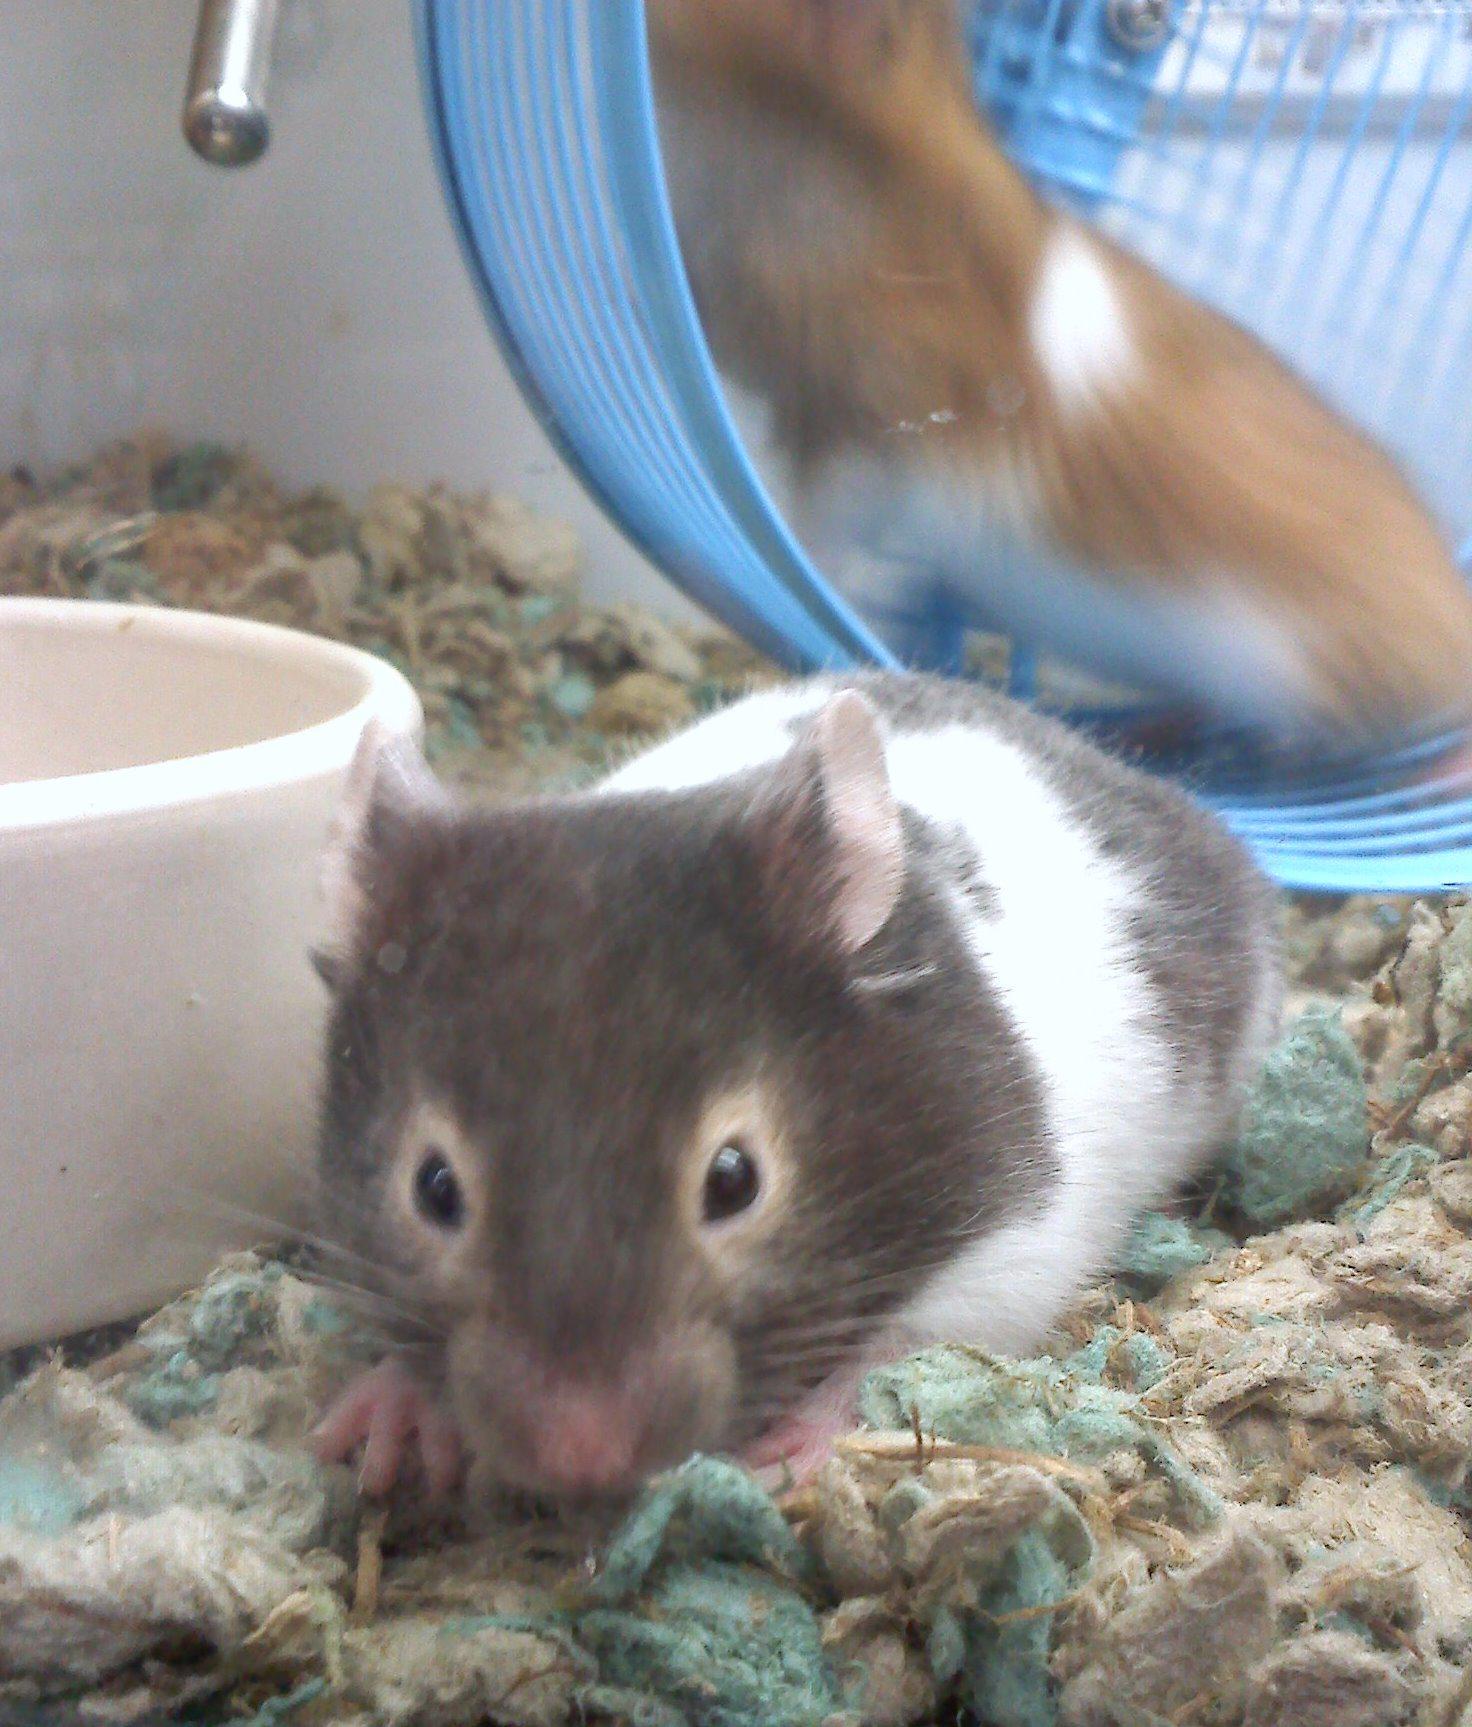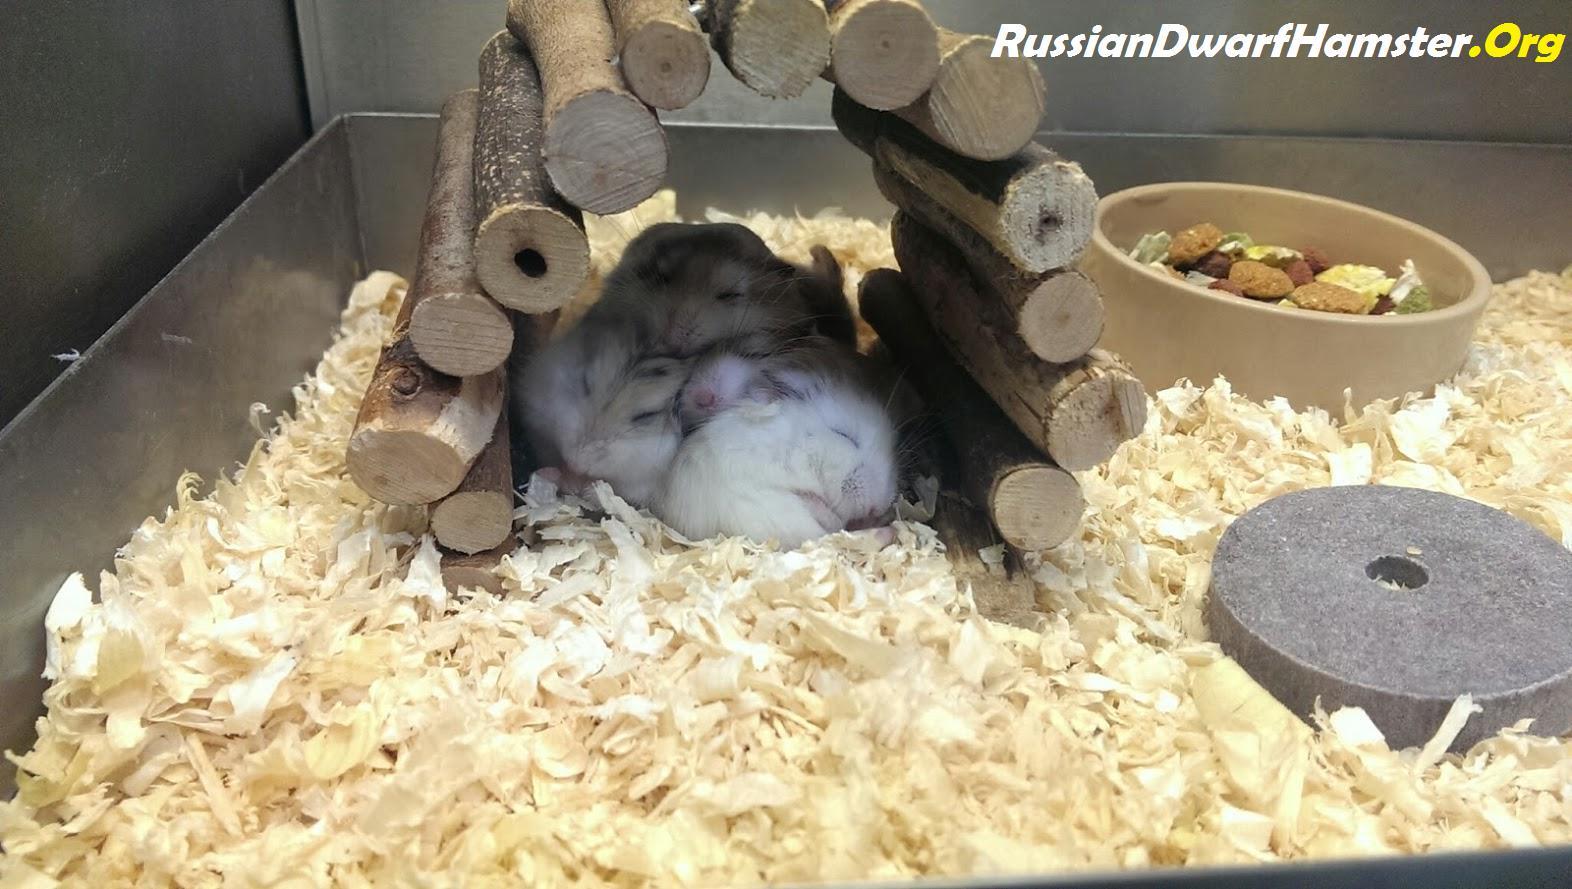The first image is the image on the left, the second image is the image on the right. Considering the images on both sides, is "An image contains two hamsters and some part of a human." valid? Answer yes or no. No. The first image is the image on the left, the second image is the image on the right. For the images shown, is this caption "A hamster is standing on its hind legs with its front legs up and not touching the ground." true? Answer yes or no. No. 